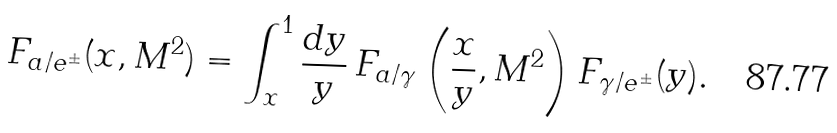<formula> <loc_0><loc_0><loc_500><loc_500>F _ { a / e ^ { \pm } } ( x , M ^ { 2 } ) = \int _ { x } ^ { 1 } \frac { d y } { y } \, F _ { a / \gamma } \left ( \frac { x } { y } , M ^ { 2 } \right ) F _ { \gamma / e ^ { \pm } } ( y ) .</formula> 